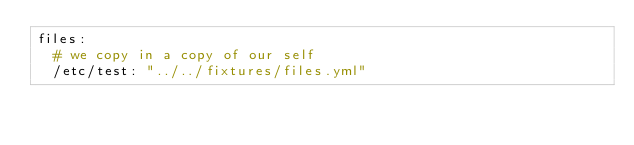<code> <loc_0><loc_0><loc_500><loc_500><_YAML_>files:
  # we copy in a copy of our self
  /etc/test: "../../fixtures/files.yml"
</code> 